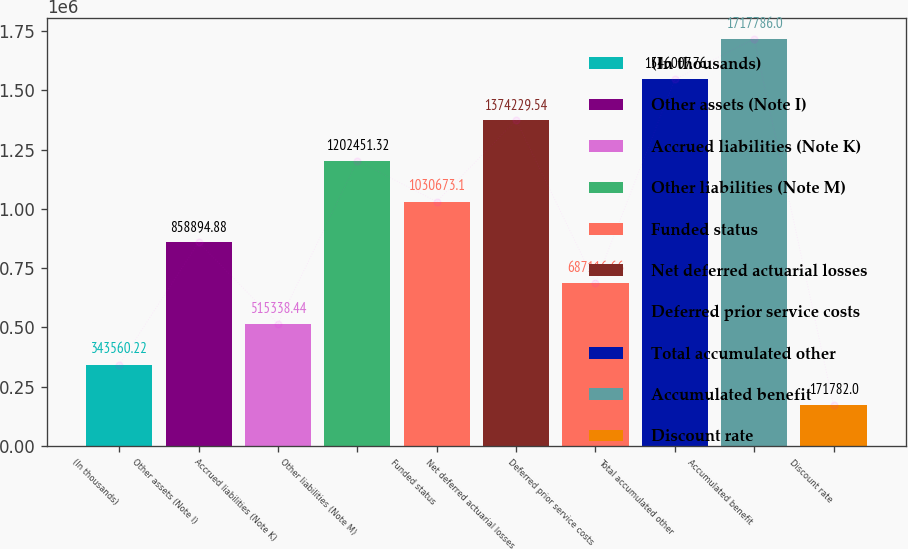Convert chart. <chart><loc_0><loc_0><loc_500><loc_500><bar_chart><fcel>(In thousands)<fcel>Other assets (Note I)<fcel>Accrued liabilities (Note K)<fcel>Other liabilities (Note M)<fcel>Funded status<fcel>Net deferred actuarial losses<fcel>Deferred prior service costs<fcel>Total accumulated other<fcel>Accumulated benefit<fcel>Discount rate<nl><fcel>343560<fcel>858895<fcel>515338<fcel>1.20245e+06<fcel>1.03067e+06<fcel>1.37423e+06<fcel>687117<fcel>1.54601e+06<fcel>1.71779e+06<fcel>171782<nl></chart> 